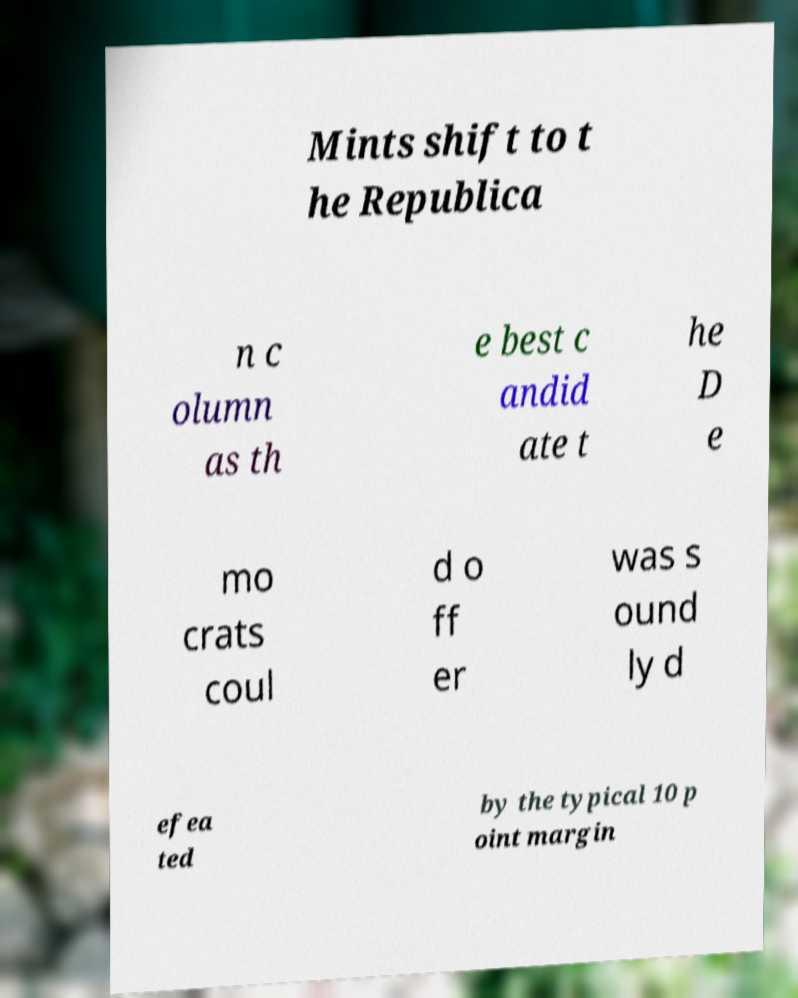There's text embedded in this image that I need extracted. Can you transcribe it verbatim? Mints shift to t he Republica n c olumn as th e best c andid ate t he D e mo crats coul d o ff er was s ound ly d efea ted by the typical 10 p oint margin 